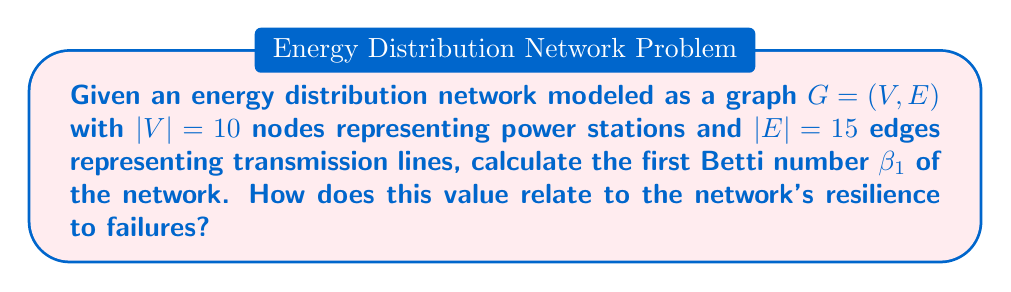Help me with this question. To solve this problem, we'll follow these steps:

1) First, recall that the first Betti number $\beta_1$ for a graph is given by:

   $$\beta_1 = |E| - |V| + \beta_0$$

   where $|E|$ is the number of edges, $|V|$ is the number of vertices, and $\beta_0$ is the number of connected components.

2) We're given that $|E| = 15$ and $|V| = 10$.

3) Assume the graph is connected (as it represents a distribution network), so $\beta_0 = 1$.

4) Substituting these values into the formula:

   $$\beta_1 = 15 - 10 + 1 = 6$$

5) The first Betti number $\beta_1$ represents the number of fundamental cycles in the graph, which in network theory corresponds to the number of alternative paths or redundancies in the system.

6) A higher $\beta_1$ indicates more alternative paths in the network. In the context of energy distribution, this means:
   - Higher resilience to failures: If one transmission line fails, there are more alternative routes for energy to flow.
   - Better load balancing capabilities: Energy can be redistributed through multiple paths, potentially reducing congestion.
   - Increased operational flexibility: Multiple routing options allow for maintenance without significant service disruptions.

7) For a data analyst in the energy industry, this metric provides insight into the robustness of the distribution network and can inform decisions about network expansion or reinforcement strategies.
Answer: $\beta_1 = 6$; higher value indicates increased network resilience. 